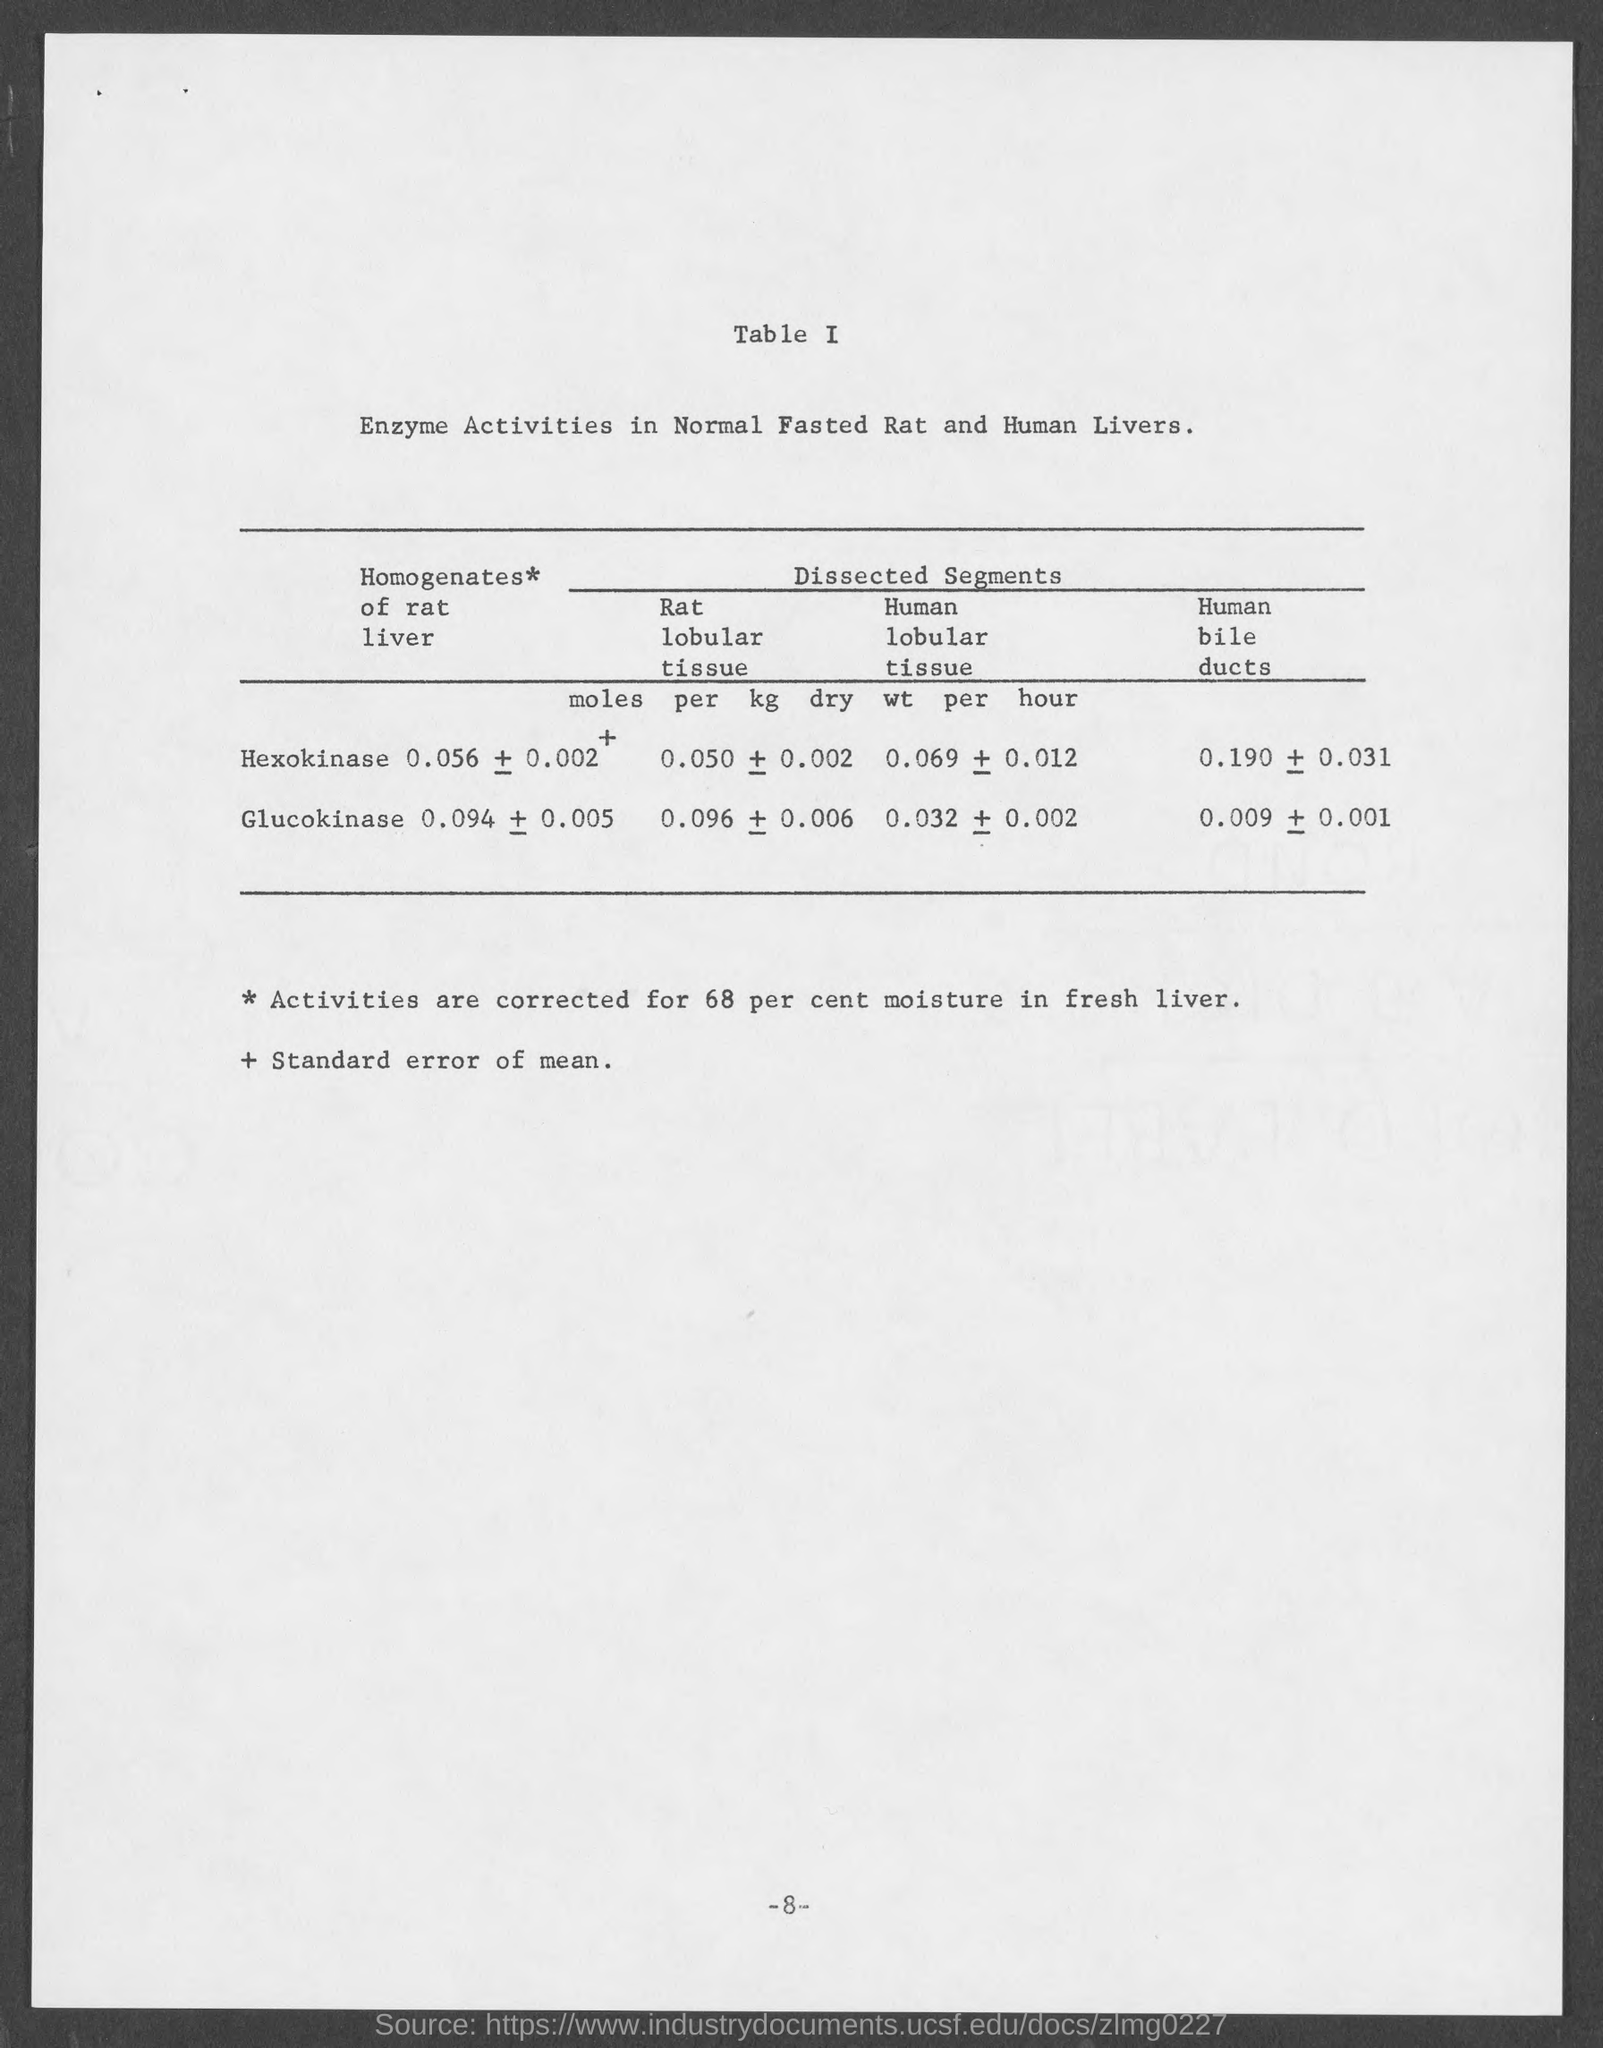What does the document describes?
Provide a short and direct response. Enzyme Activities in Normal Fasted Rat and Human Livers. 